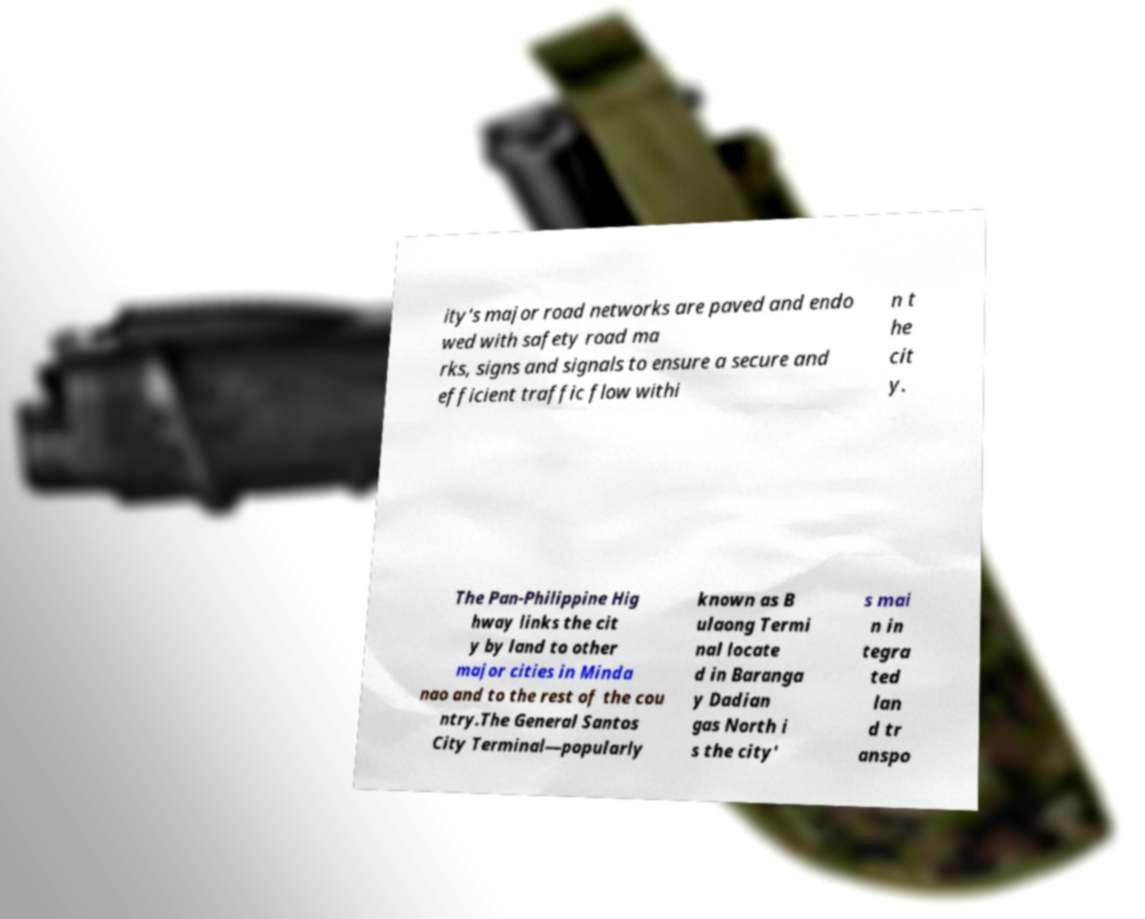Please read and relay the text visible in this image. What does it say? ity's major road networks are paved and endo wed with safety road ma rks, signs and signals to ensure a secure and efficient traffic flow withi n t he cit y. The Pan-Philippine Hig hway links the cit y by land to other major cities in Minda nao and to the rest of the cou ntry.The General Santos City Terminal—popularly known as B ulaong Termi nal locate d in Baranga y Dadian gas North i s the city' s mai n in tegra ted lan d tr anspo 